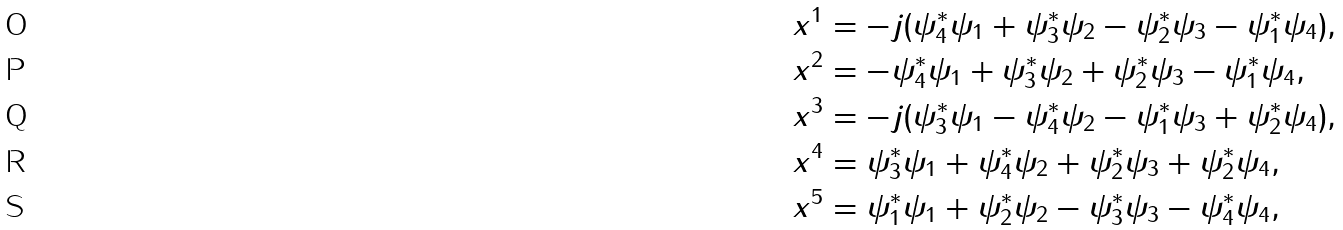Convert formula to latex. <formula><loc_0><loc_0><loc_500><loc_500>& x ^ { 1 } = - j ( \psi _ { 4 } ^ { * } \psi _ { 1 } + \psi _ { 3 } ^ { * } \psi _ { 2 } - \psi _ { 2 } ^ { * } \psi _ { 3 } - \psi _ { 1 } ^ { * } \psi _ { 4 } ) , \\ & x ^ { 2 } = - \psi _ { 4 } ^ { * } \psi _ { 1 } + \psi _ { 3 } ^ { * } \psi _ { 2 } + \psi _ { 2 } ^ { * } \psi _ { 3 } - \psi _ { 1 } ^ { * } \psi _ { 4 } , \\ & x ^ { 3 } = - j ( \psi _ { 3 } ^ { * } \psi _ { 1 } - \psi _ { 4 } ^ { * } \psi _ { 2 } - \psi _ { 1 } ^ { * } \psi _ { 3 } + \psi _ { 2 } ^ { * } \psi _ { 4 } ) , \\ & x ^ { 4 } = \psi _ { 3 } ^ { * } \psi _ { 1 } + \psi _ { 4 } ^ { * } \psi _ { 2 } + \psi _ { 2 } ^ { * } \psi _ { 3 } + \psi _ { 2 } ^ { * } \psi _ { 4 } , \\ & x ^ { 5 } = \psi _ { 1 } ^ { * } \psi _ { 1 } + \psi _ { 2 } ^ { * } \psi _ { 2 } - \psi _ { 3 } ^ { * } \psi _ { 3 } - \psi _ { 4 } ^ { * } \psi _ { 4 } ,</formula> 